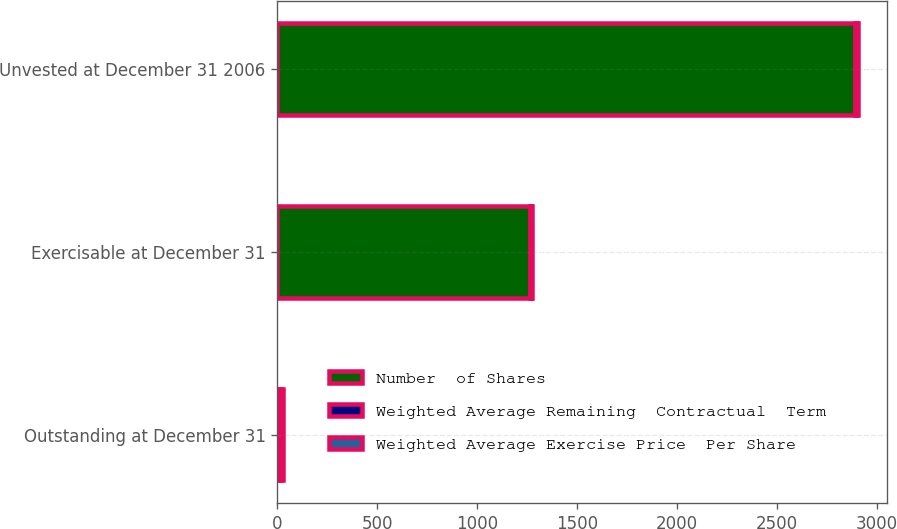Convert chart. <chart><loc_0><loc_0><loc_500><loc_500><stacked_bar_chart><ecel><fcel>Outstanding at December 31<fcel>Exercisable at December 31<fcel>Unvested at December 31 2006<nl><fcel>Number  of Shares<fcel>8.935<fcel>1263<fcel>2889<nl><fcel>Weighted Average Remaining  Contractual  Term<fcel>9.87<fcel>6.7<fcel>11.26<nl><fcel>Weighted Average Exercise Price  Per Share<fcel>7.4<fcel>6<fcel>8<nl></chart> 